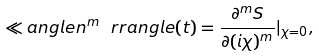<formula> <loc_0><loc_0><loc_500><loc_500>\ll a n g l e n ^ { m } \ r r a n g l e ( t ) = \frac { \partial ^ { m } S } { \partial ( i \chi ) ^ { m } } | _ { \chi = 0 } ,</formula> 